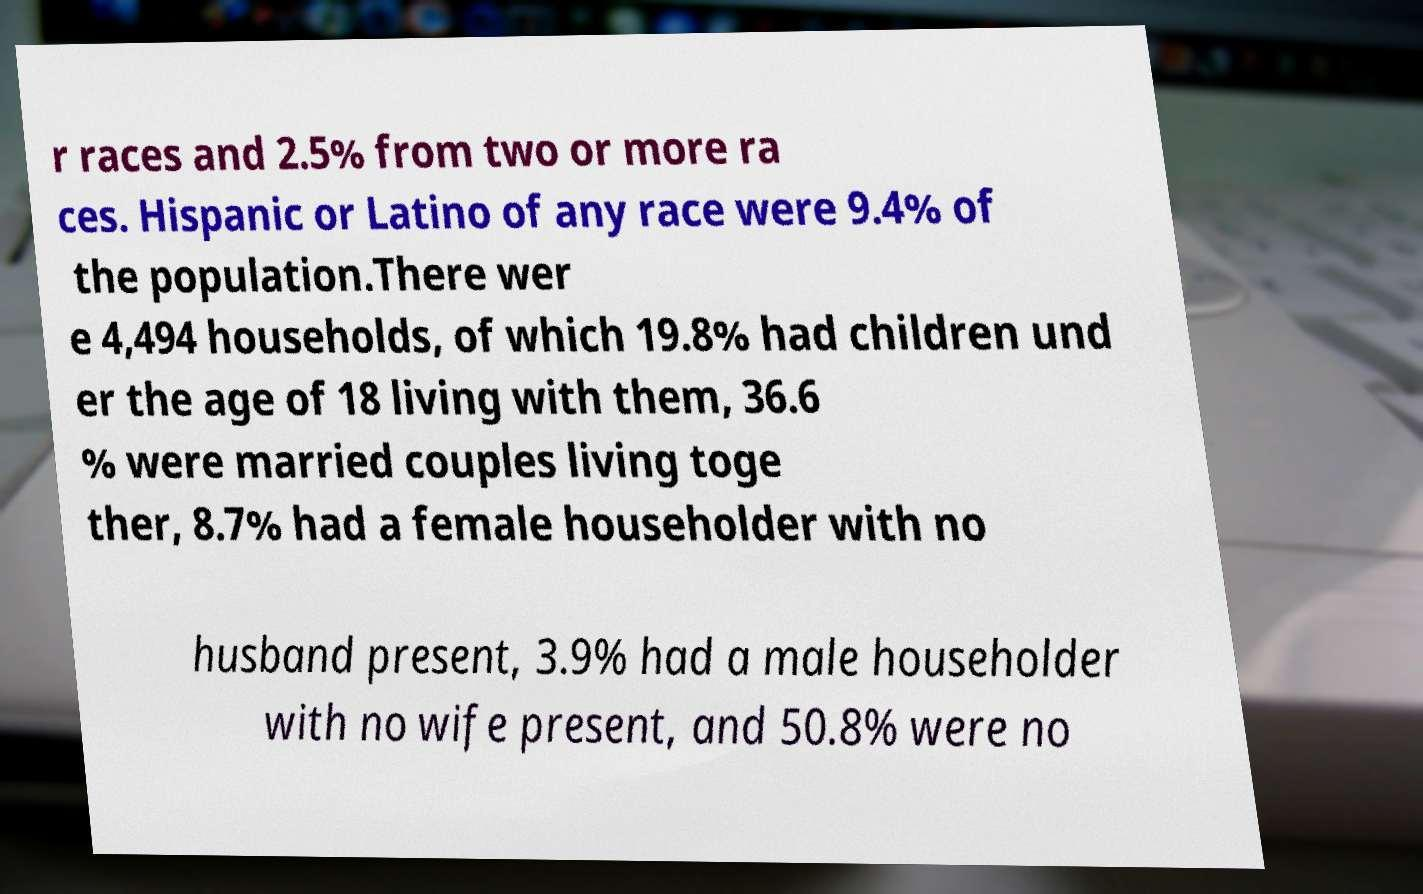Please read and relay the text visible in this image. What does it say? r races and 2.5% from two or more ra ces. Hispanic or Latino of any race were 9.4% of the population.There wer e 4,494 households, of which 19.8% had children und er the age of 18 living with them, 36.6 % were married couples living toge ther, 8.7% had a female householder with no husband present, 3.9% had a male householder with no wife present, and 50.8% were no 